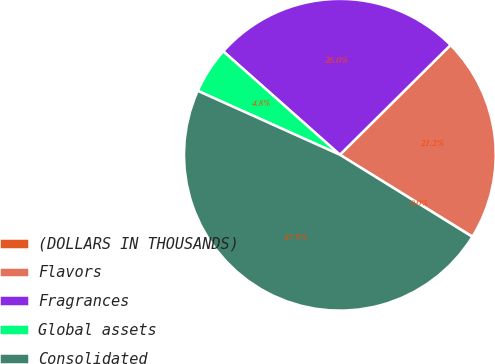Convert chart. <chart><loc_0><loc_0><loc_500><loc_500><pie_chart><fcel>(DOLLARS IN THOUSANDS)<fcel>Flavors<fcel>Fragrances<fcel>Global assets<fcel>Consolidated<nl><fcel>0.03%<fcel>21.23%<fcel>26.02%<fcel>4.82%<fcel>47.9%<nl></chart> 